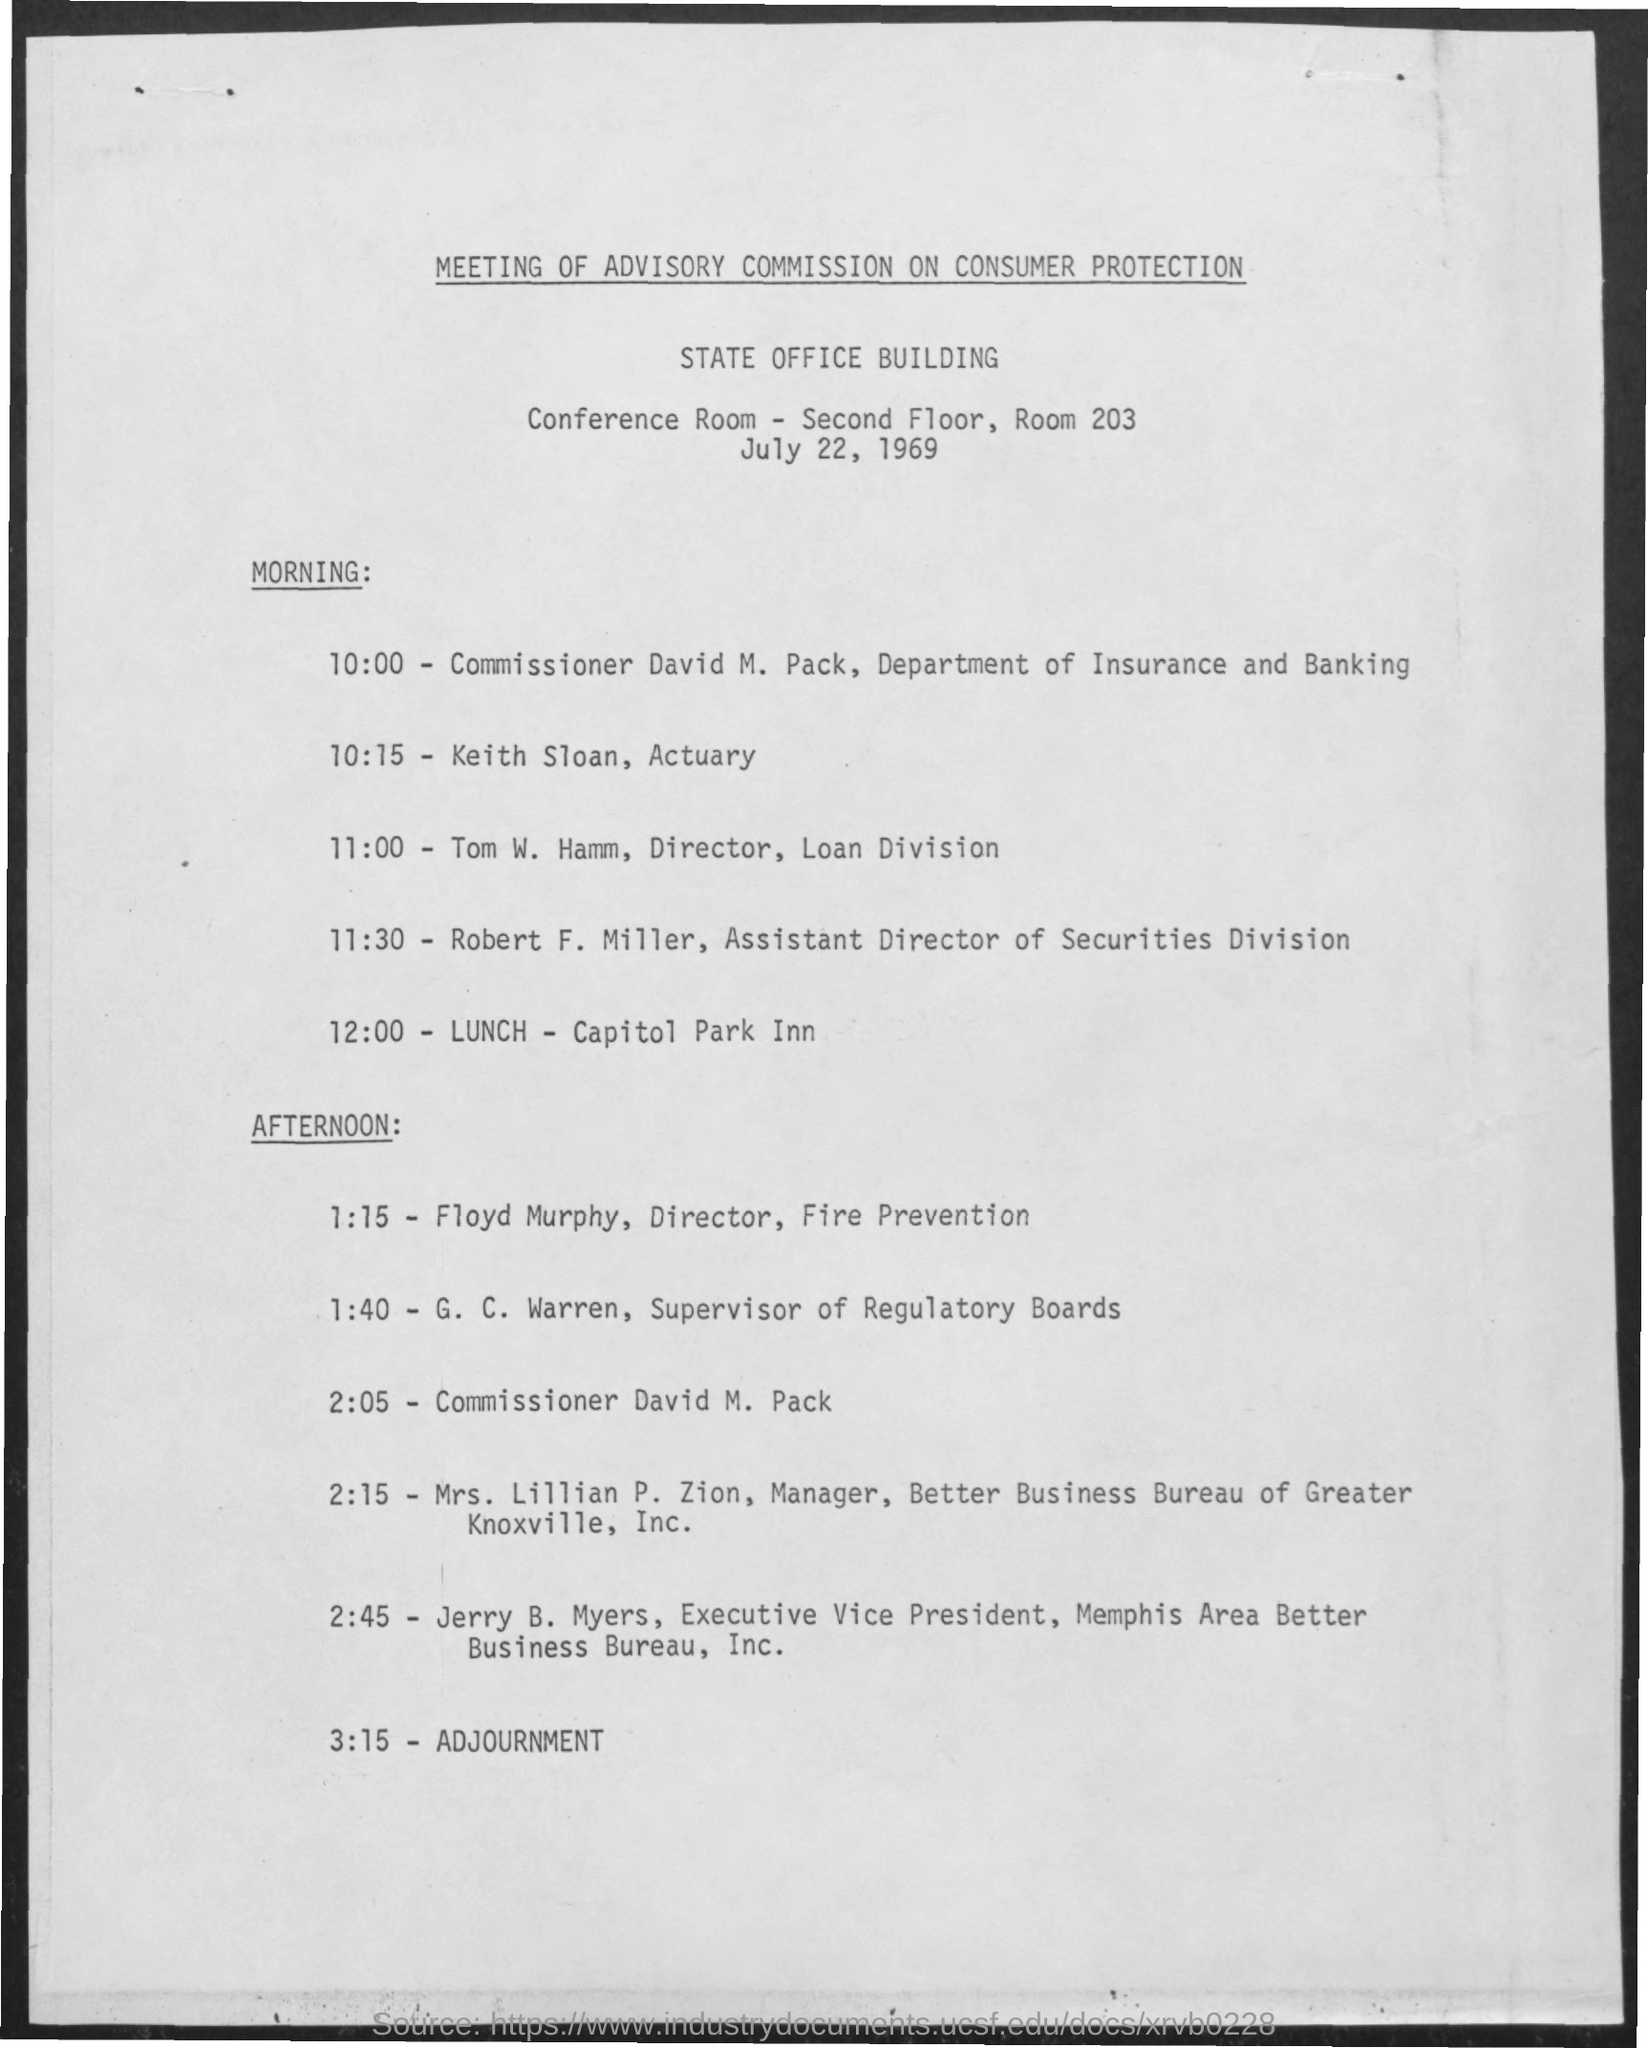what is the conference room no
 203 